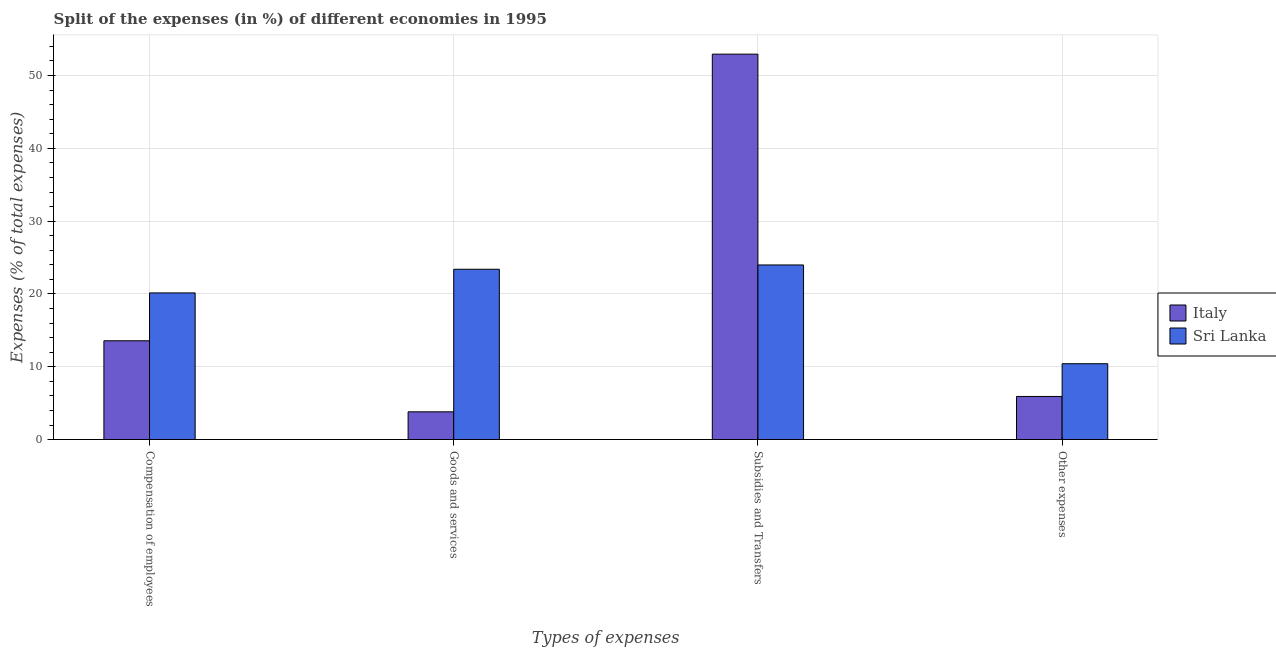How many groups of bars are there?
Make the answer very short. 4. Are the number of bars per tick equal to the number of legend labels?
Ensure brevity in your answer.  Yes. Are the number of bars on each tick of the X-axis equal?
Your answer should be very brief. Yes. How many bars are there on the 1st tick from the left?
Your answer should be compact. 2. How many bars are there on the 1st tick from the right?
Offer a terse response. 2. What is the label of the 3rd group of bars from the left?
Offer a terse response. Subsidies and Transfers. What is the percentage of amount spent on compensation of employees in Italy?
Your answer should be very brief. 13.57. Across all countries, what is the maximum percentage of amount spent on compensation of employees?
Offer a terse response. 20.14. Across all countries, what is the minimum percentage of amount spent on other expenses?
Your answer should be compact. 5.93. In which country was the percentage of amount spent on compensation of employees maximum?
Your answer should be compact. Sri Lanka. What is the total percentage of amount spent on compensation of employees in the graph?
Your response must be concise. 33.72. What is the difference between the percentage of amount spent on subsidies in Italy and that in Sri Lanka?
Offer a terse response. 28.95. What is the difference between the percentage of amount spent on goods and services in Italy and the percentage of amount spent on compensation of employees in Sri Lanka?
Offer a very short reply. -16.33. What is the average percentage of amount spent on goods and services per country?
Offer a very short reply. 13.6. What is the difference between the percentage of amount spent on subsidies and percentage of amount spent on compensation of employees in Sri Lanka?
Give a very brief answer. 3.84. In how many countries, is the percentage of amount spent on goods and services greater than 32 %?
Offer a very short reply. 0. What is the ratio of the percentage of amount spent on other expenses in Italy to that in Sri Lanka?
Give a very brief answer. 0.57. Is the percentage of amount spent on goods and services in Sri Lanka less than that in Italy?
Make the answer very short. No. What is the difference between the highest and the second highest percentage of amount spent on other expenses?
Keep it short and to the point. 4.5. What is the difference between the highest and the lowest percentage of amount spent on goods and services?
Offer a very short reply. 19.58. In how many countries, is the percentage of amount spent on compensation of employees greater than the average percentage of amount spent on compensation of employees taken over all countries?
Give a very brief answer. 1. Is it the case that in every country, the sum of the percentage of amount spent on goods and services and percentage of amount spent on subsidies is greater than the sum of percentage of amount spent on compensation of employees and percentage of amount spent on other expenses?
Your answer should be very brief. Yes. What does the 2nd bar from the left in Subsidies and Transfers represents?
Your response must be concise. Sri Lanka. What does the 2nd bar from the right in Goods and services represents?
Keep it short and to the point. Italy. Are all the bars in the graph horizontal?
Your answer should be compact. No. How many countries are there in the graph?
Offer a terse response. 2. What is the difference between two consecutive major ticks on the Y-axis?
Keep it short and to the point. 10. Are the values on the major ticks of Y-axis written in scientific E-notation?
Offer a terse response. No. Does the graph contain any zero values?
Your response must be concise. No. Does the graph contain grids?
Provide a short and direct response. Yes. What is the title of the graph?
Give a very brief answer. Split of the expenses (in %) of different economies in 1995. Does "Bolivia" appear as one of the legend labels in the graph?
Your response must be concise. No. What is the label or title of the X-axis?
Your answer should be very brief. Types of expenses. What is the label or title of the Y-axis?
Offer a terse response. Expenses (% of total expenses). What is the Expenses (% of total expenses) of Italy in Compensation of employees?
Make the answer very short. 13.57. What is the Expenses (% of total expenses) of Sri Lanka in Compensation of employees?
Keep it short and to the point. 20.14. What is the Expenses (% of total expenses) in Italy in Goods and services?
Give a very brief answer. 3.82. What is the Expenses (% of total expenses) of Sri Lanka in Goods and services?
Ensure brevity in your answer.  23.39. What is the Expenses (% of total expenses) of Italy in Subsidies and Transfers?
Your answer should be very brief. 52.93. What is the Expenses (% of total expenses) of Sri Lanka in Subsidies and Transfers?
Offer a very short reply. 23.98. What is the Expenses (% of total expenses) of Italy in Other expenses?
Provide a succinct answer. 5.93. What is the Expenses (% of total expenses) in Sri Lanka in Other expenses?
Your answer should be very brief. 10.42. Across all Types of expenses, what is the maximum Expenses (% of total expenses) of Italy?
Offer a very short reply. 52.93. Across all Types of expenses, what is the maximum Expenses (% of total expenses) of Sri Lanka?
Provide a short and direct response. 23.98. Across all Types of expenses, what is the minimum Expenses (% of total expenses) of Italy?
Offer a terse response. 3.82. Across all Types of expenses, what is the minimum Expenses (% of total expenses) in Sri Lanka?
Your response must be concise. 10.42. What is the total Expenses (% of total expenses) in Italy in the graph?
Keep it short and to the point. 76.25. What is the total Expenses (% of total expenses) of Sri Lanka in the graph?
Provide a succinct answer. 77.94. What is the difference between the Expenses (% of total expenses) in Italy in Compensation of employees and that in Goods and services?
Keep it short and to the point. 9.76. What is the difference between the Expenses (% of total expenses) in Sri Lanka in Compensation of employees and that in Goods and services?
Ensure brevity in your answer.  -3.25. What is the difference between the Expenses (% of total expenses) of Italy in Compensation of employees and that in Subsidies and Transfers?
Make the answer very short. -39.36. What is the difference between the Expenses (% of total expenses) in Sri Lanka in Compensation of employees and that in Subsidies and Transfers?
Provide a short and direct response. -3.84. What is the difference between the Expenses (% of total expenses) in Italy in Compensation of employees and that in Other expenses?
Ensure brevity in your answer.  7.65. What is the difference between the Expenses (% of total expenses) of Sri Lanka in Compensation of employees and that in Other expenses?
Your response must be concise. 9.72. What is the difference between the Expenses (% of total expenses) in Italy in Goods and services and that in Subsidies and Transfers?
Your response must be concise. -49.12. What is the difference between the Expenses (% of total expenses) of Sri Lanka in Goods and services and that in Subsidies and Transfers?
Your response must be concise. -0.59. What is the difference between the Expenses (% of total expenses) of Italy in Goods and services and that in Other expenses?
Your response must be concise. -2.11. What is the difference between the Expenses (% of total expenses) of Sri Lanka in Goods and services and that in Other expenses?
Ensure brevity in your answer.  12.97. What is the difference between the Expenses (% of total expenses) of Italy in Subsidies and Transfers and that in Other expenses?
Offer a very short reply. 47.01. What is the difference between the Expenses (% of total expenses) in Sri Lanka in Subsidies and Transfers and that in Other expenses?
Keep it short and to the point. 13.56. What is the difference between the Expenses (% of total expenses) in Italy in Compensation of employees and the Expenses (% of total expenses) in Sri Lanka in Goods and services?
Provide a succinct answer. -9.82. What is the difference between the Expenses (% of total expenses) in Italy in Compensation of employees and the Expenses (% of total expenses) in Sri Lanka in Subsidies and Transfers?
Give a very brief answer. -10.41. What is the difference between the Expenses (% of total expenses) in Italy in Compensation of employees and the Expenses (% of total expenses) in Sri Lanka in Other expenses?
Give a very brief answer. 3.15. What is the difference between the Expenses (% of total expenses) of Italy in Goods and services and the Expenses (% of total expenses) of Sri Lanka in Subsidies and Transfers?
Your response must be concise. -20.17. What is the difference between the Expenses (% of total expenses) of Italy in Goods and services and the Expenses (% of total expenses) of Sri Lanka in Other expenses?
Ensure brevity in your answer.  -6.6. What is the difference between the Expenses (% of total expenses) of Italy in Subsidies and Transfers and the Expenses (% of total expenses) of Sri Lanka in Other expenses?
Offer a terse response. 42.51. What is the average Expenses (% of total expenses) of Italy per Types of expenses?
Offer a terse response. 19.06. What is the average Expenses (% of total expenses) in Sri Lanka per Types of expenses?
Provide a short and direct response. 19.49. What is the difference between the Expenses (% of total expenses) of Italy and Expenses (% of total expenses) of Sri Lanka in Compensation of employees?
Your answer should be very brief. -6.57. What is the difference between the Expenses (% of total expenses) of Italy and Expenses (% of total expenses) of Sri Lanka in Goods and services?
Your response must be concise. -19.58. What is the difference between the Expenses (% of total expenses) in Italy and Expenses (% of total expenses) in Sri Lanka in Subsidies and Transfers?
Your response must be concise. 28.95. What is the difference between the Expenses (% of total expenses) in Italy and Expenses (% of total expenses) in Sri Lanka in Other expenses?
Provide a succinct answer. -4.5. What is the ratio of the Expenses (% of total expenses) of Italy in Compensation of employees to that in Goods and services?
Ensure brevity in your answer.  3.56. What is the ratio of the Expenses (% of total expenses) of Sri Lanka in Compensation of employees to that in Goods and services?
Ensure brevity in your answer.  0.86. What is the ratio of the Expenses (% of total expenses) of Italy in Compensation of employees to that in Subsidies and Transfers?
Your answer should be compact. 0.26. What is the ratio of the Expenses (% of total expenses) of Sri Lanka in Compensation of employees to that in Subsidies and Transfers?
Offer a very short reply. 0.84. What is the ratio of the Expenses (% of total expenses) in Italy in Compensation of employees to that in Other expenses?
Your answer should be very brief. 2.29. What is the ratio of the Expenses (% of total expenses) of Sri Lanka in Compensation of employees to that in Other expenses?
Ensure brevity in your answer.  1.93. What is the ratio of the Expenses (% of total expenses) of Italy in Goods and services to that in Subsidies and Transfers?
Keep it short and to the point. 0.07. What is the ratio of the Expenses (% of total expenses) in Sri Lanka in Goods and services to that in Subsidies and Transfers?
Make the answer very short. 0.98. What is the ratio of the Expenses (% of total expenses) in Italy in Goods and services to that in Other expenses?
Make the answer very short. 0.64. What is the ratio of the Expenses (% of total expenses) in Sri Lanka in Goods and services to that in Other expenses?
Offer a terse response. 2.24. What is the ratio of the Expenses (% of total expenses) of Italy in Subsidies and Transfers to that in Other expenses?
Your response must be concise. 8.93. What is the ratio of the Expenses (% of total expenses) of Sri Lanka in Subsidies and Transfers to that in Other expenses?
Offer a terse response. 2.3. What is the difference between the highest and the second highest Expenses (% of total expenses) of Italy?
Make the answer very short. 39.36. What is the difference between the highest and the second highest Expenses (% of total expenses) in Sri Lanka?
Your answer should be compact. 0.59. What is the difference between the highest and the lowest Expenses (% of total expenses) of Italy?
Your answer should be compact. 49.12. What is the difference between the highest and the lowest Expenses (% of total expenses) in Sri Lanka?
Provide a succinct answer. 13.56. 